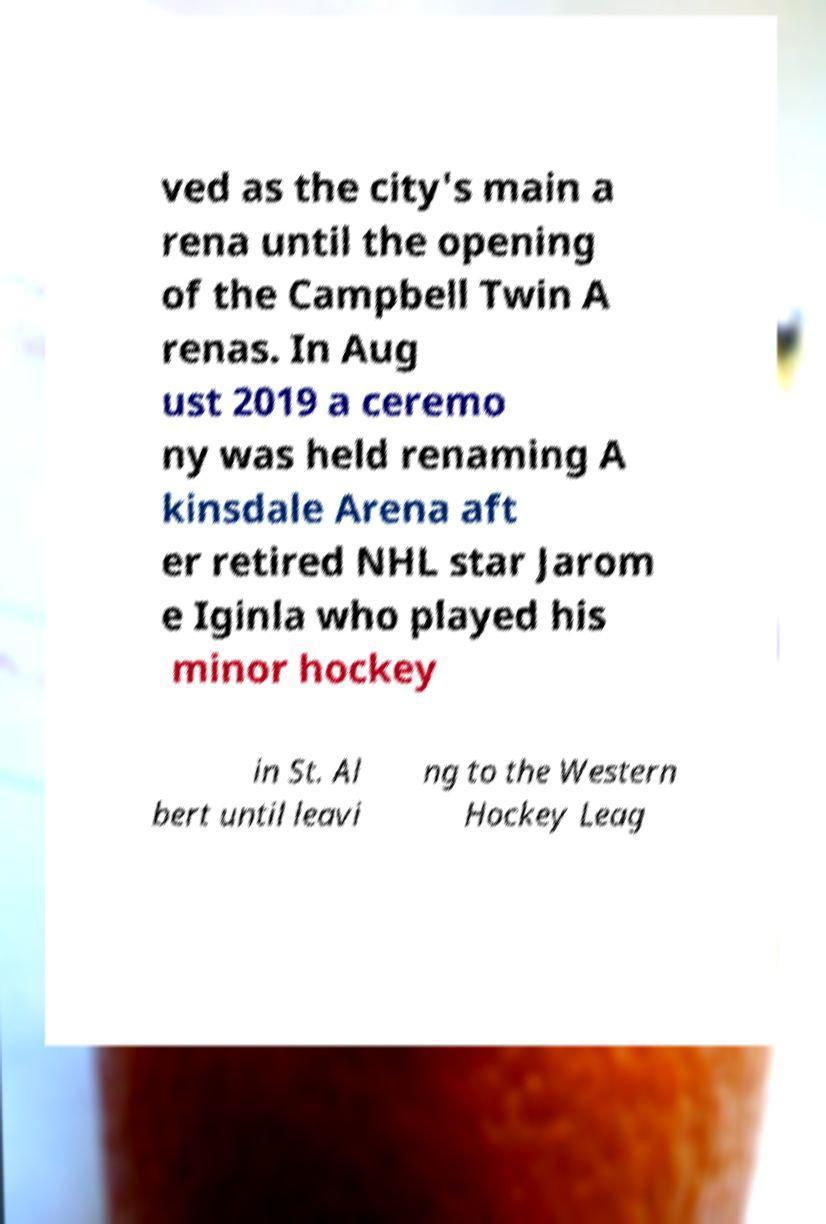What messages or text are displayed in this image? I need them in a readable, typed format. ved as the city's main a rena until the opening of the Campbell Twin A renas. In Aug ust 2019 a ceremo ny was held renaming A kinsdale Arena aft er retired NHL star Jarom e Iginla who played his minor hockey in St. Al bert until leavi ng to the Western Hockey Leag 